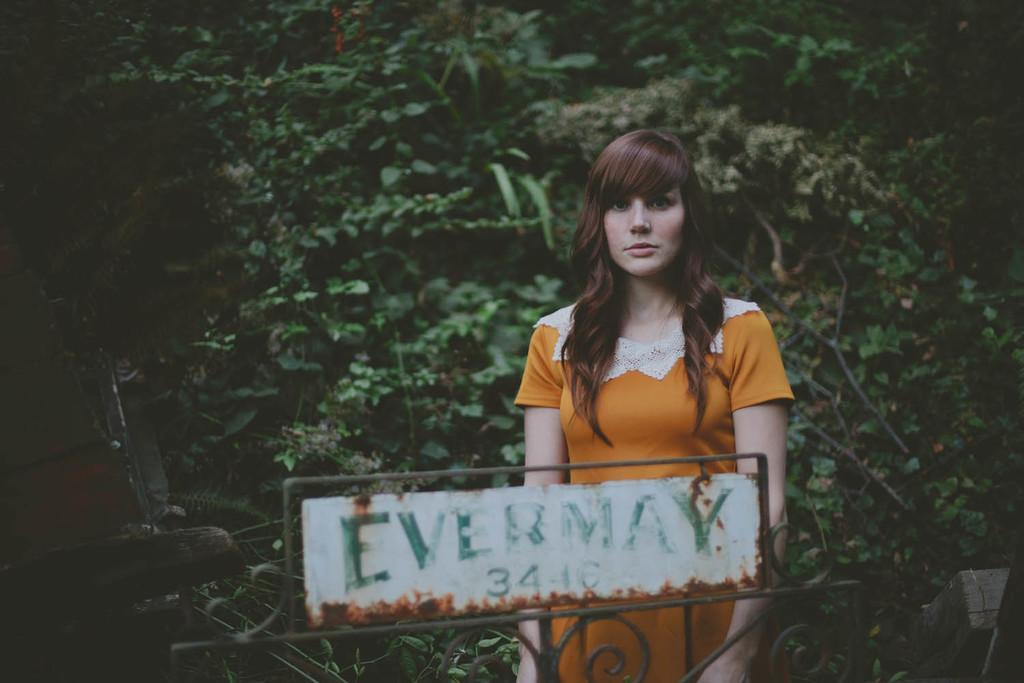Describe this image in one or two sentences. In this image I can see a board in front, on which there is a word and numbers written and behind the board I can see a woman who is wearing white and orange color dress. In the background I can see the trees. 